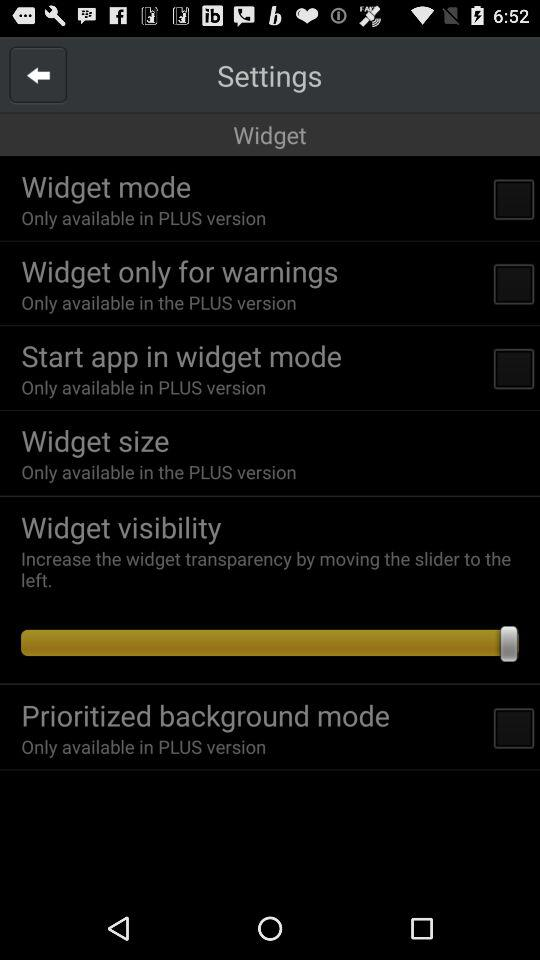How many checkboxes are in the widget settings screen?
Answer the question using a single word or phrase. 4 